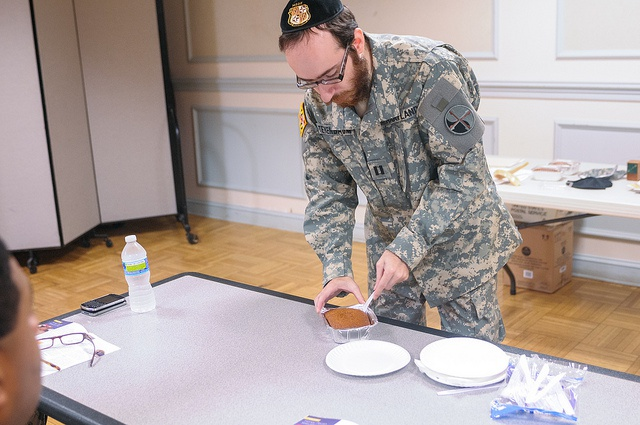Describe the objects in this image and their specific colors. I can see dining table in gray, lavender, darkgray, and lightgray tones, people in gray, darkgray, lightpink, and black tones, people in gray, black, and brown tones, bottle in gray, lavender, khaki, and lightblue tones, and cake in gray, salmon, and red tones in this image. 